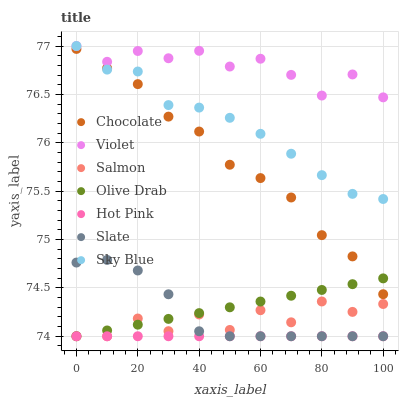Does Hot Pink have the minimum area under the curve?
Answer yes or no. Yes. Does Violet have the maximum area under the curve?
Answer yes or no. Yes. Does Salmon have the minimum area under the curve?
Answer yes or no. No. Does Salmon have the maximum area under the curve?
Answer yes or no. No. Is Hot Pink the smoothest?
Answer yes or no. Yes. Is Salmon the roughest?
Answer yes or no. Yes. Is Salmon the smoothest?
Answer yes or no. No. Is Hot Pink the roughest?
Answer yes or no. No. Does Slate have the lowest value?
Answer yes or no. Yes. Does Chocolate have the lowest value?
Answer yes or no. No. Does Sky Blue have the highest value?
Answer yes or no. Yes. Does Salmon have the highest value?
Answer yes or no. No. Is Salmon less than Chocolate?
Answer yes or no. Yes. Is Sky Blue greater than Slate?
Answer yes or no. Yes. Does Olive Drab intersect Salmon?
Answer yes or no. Yes. Is Olive Drab less than Salmon?
Answer yes or no. No. Is Olive Drab greater than Salmon?
Answer yes or no. No. Does Salmon intersect Chocolate?
Answer yes or no. No. 